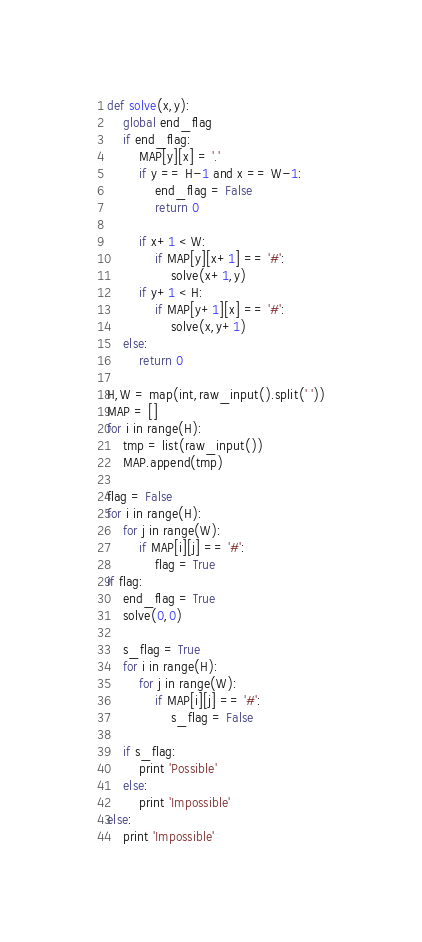Convert code to text. <code><loc_0><loc_0><loc_500><loc_500><_Python_>def solve(x,y):
    global end_flag
    if end_flag:
        MAP[y][x] = '.'
        if y == H-1 and x == W-1:
            end_flag = False
            return 0

        if x+1 < W:
            if MAP[y][x+1] == '#':
                solve(x+1,y)
        if y+1 < H:
            if MAP[y+1][x] == '#':
                solve(x,y+1)
    else:
        return 0

H,W = map(int,raw_input().split(' '))
MAP = []
for i in range(H):
    tmp = list(raw_input())
    MAP.append(tmp)

flag = False
for i in range(H):
    for j in range(W):
        if MAP[i][j] == '#':
            flag = True
if flag:
    end_flag = True
    solve(0,0)

    s_flag = True
    for i in range(H):
        for j in range(W):
            if MAP[i][j] == '#':
                s_flag = False

    if s_flag:
        print 'Possible'
    else:
        print 'Impossible'
else:
    print 'Impossible'
</code> 